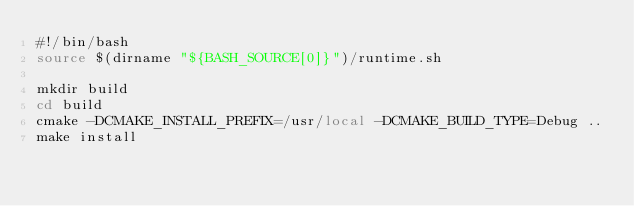<code> <loc_0><loc_0><loc_500><loc_500><_Bash_>#!/bin/bash
source $(dirname "${BASH_SOURCE[0]}")/runtime.sh

mkdir build
cd build
cmake -DCMAKE_INSTALL_PREFIX=/usr/local -DCMAKE_BUILD_TYPE=Debug ..
make install
</code> 